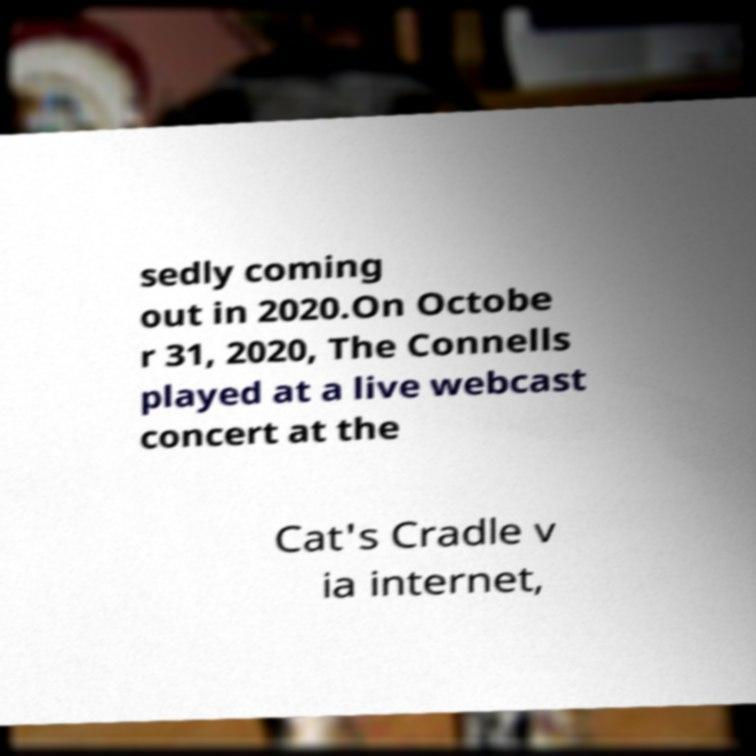Can you read and provide the text displayed in the image?This photo seems to have some interesting text. Can you extract and type it out for me? sedly coming out in 2020.On Octobe r 31, 2020, The Connells played at a live webcast concert at the Cat's Cradle v ia internet, 